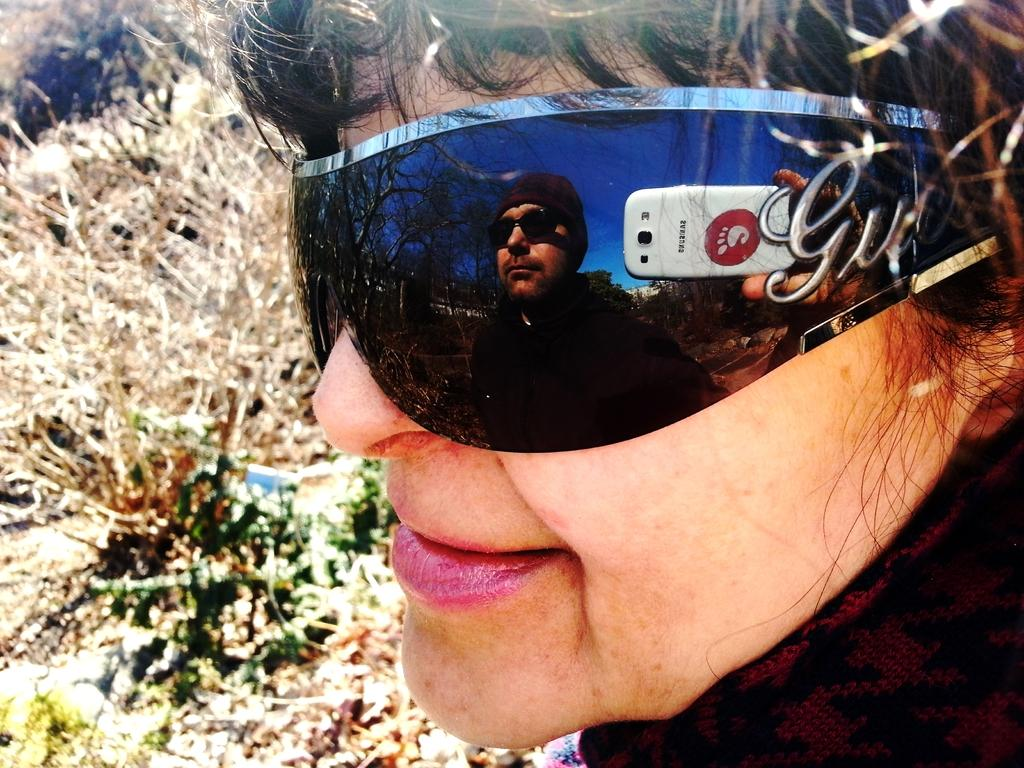Who is present in the image? There is a woman in the image. What is the woman wearing? The woman is wearing glasses. Can you describe the reflection in her glasses? A person holding a mobile is reflected in her glasses. What can be seen in the background of the image? There are plants visible in the background of the image. What type of reward is the woman holding in the image? There is no reward visible in the image; the woman is wearing glasses and there is a reflection of a person holding a mobile. 